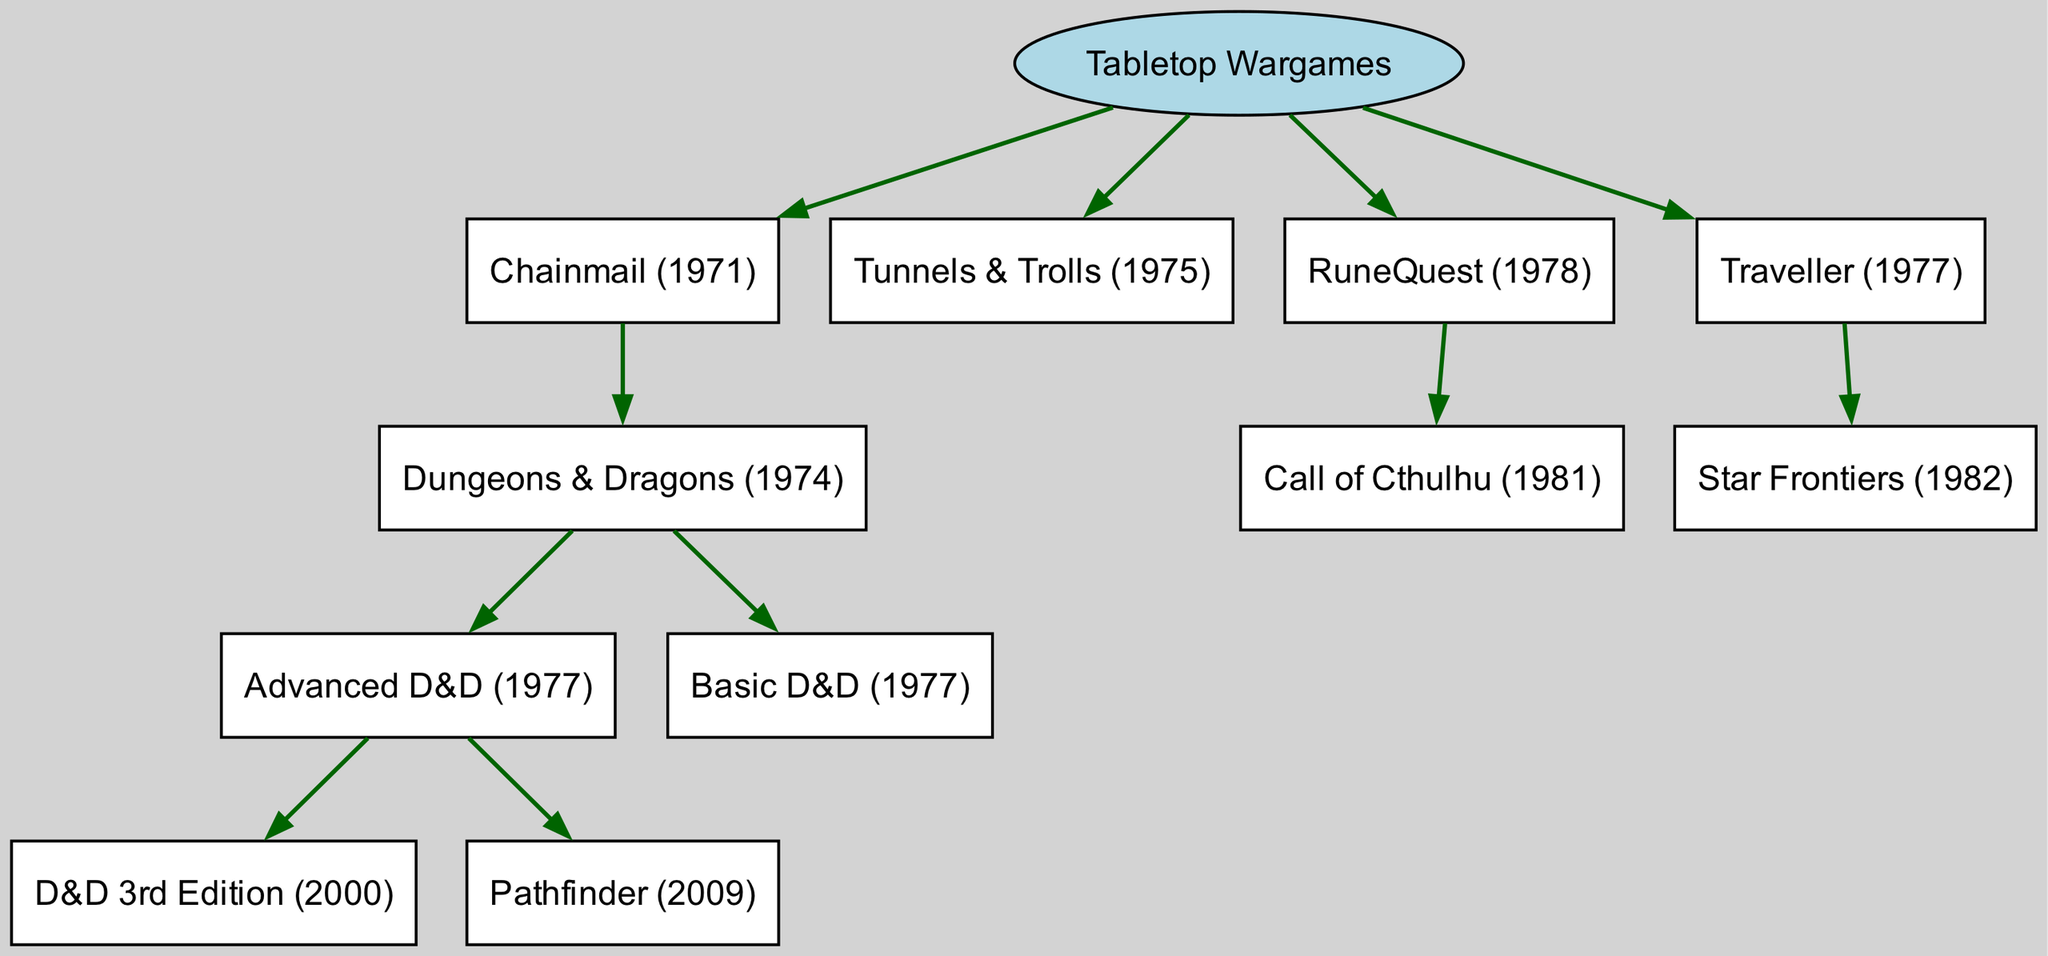What is the root of the family tree? The diagram starts with "Tabletop Wargames" as the root node, indicating that this is the primary category from which other types of games are derived.
Answer: Tabletop Wargames How many children does "Chainmail (1971)" have? The node "Chainmail (1971)" has one direct child, which is "Dungeons & Dragons (1974)", representing its only offshoot.
Answer: 1 Which edition is a direct child of "Dungeons & Dragons (1974)"? The direct children of "Dungeons & Dragons (1974)" include "Advanced D&D (1977)" and "Basic D&D (1977)", indicating that these are both offspring of the original game.
Answer: Advanced D&D (1977), Basic D&D (1977) What is the publication year of "Pathfinder"? "Pathfinder (2009)" is listed as a child of "Advanced D&D (1977)", thus the year of publication can be found directly associated with the node.
Answer: 2009 Which game directly follows "Traveller (1977)" in the diagram? "Traveller (1977)" has one child, which is "Star Frontiers (1982)", linking it directly under the Traveller title in the hierarchy.
Answer: Star Frontiers (1982) What relationship does "Call of Cthulhu (1981)" have with "RuneQuest (1978)"? "Call of Cthulhu (1981)" is a child node of "RuneQuest (1978)", indicating that it is derived from this game, showing a direct lineage in the family tree.
Answer: Child How many total editions are listed under "Dungeons & Dragons"? The titles associated with "Dungeons & Dragons" include "Advanced D&D (1977)", "Basic D&D (1977)", and "D&D 3rd Edition (2000)", along with "Pathfinder (2009)", totaling four distinct editions when counting all directly linked games.
Answer: 4 Which game serves as a sibling to "Tunnels & Trolls (1975)"? The sibling to "Tunnels & Trolls (1975)" can be determined by locating other primary children of the root. Both "Chainmail (1971)" and "RuneQuest (1978)" can be found at the same hierarchical level, making either one a sibling.
Answer: Chainmail (1971) or RuneQuest (1978) What is the direct ancestor of "Dungeons & Dragons"? The parent node directly above "Dungeons & Dragons (1974)" is "Chainmail (1971)", indicating that it is the direct predecessor or ancestor of the D&D series.
Answer: Chainmail (1971) 